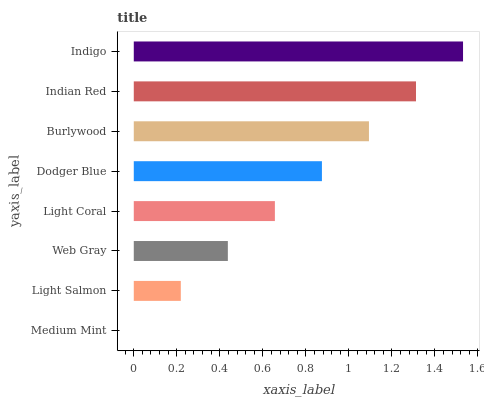Is Medium Mint the minimum?
Answer yes or no. Yes. Is Indigo the maximum?
Answer yes or no. Yes. Is Light Salmon the minimum?
Answer yes or no. No. Is Light Salmon the maximum?
Answer yes or no. No. Is Light Salmon greater than Medium Mint?
Answer yes or no. Yes. Is Medium Mint less than Light Salmon?
Answer yes or no. Yes. Is Medium Mint greater than Light Salmon?
Answer yes or no. No. Is Light Salmon less than Medium Mint?
Answer yes or no. No. Is Dodger Blue the high median?
Answer yes or no. Yes. Is Light Coral the low median?
Answer yes or no. Yes. Is Web Gray the high median?
Answer yes or no. No. Is Dodger Blue the low median?
Answer yes or no. No. 